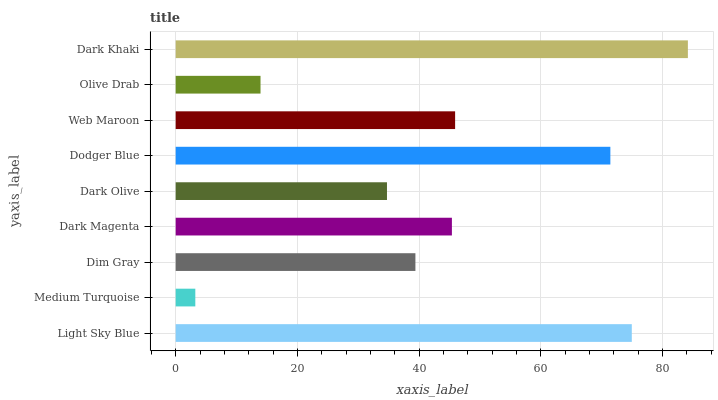Is Medium Turquoise the minimum?
Answer yes or no. Yes. Is Dark Khaki the maximum?
Answer yes or no. Yes. Is Dim Gray the minimum?
Answer yes or no. No. Is Dim Gray the maximum?
Answer yes or no. No. Is Dim Gray greater than Medium Turquoise?
Answer yes or no. Yes. Is Medium Turquoise less than Dim Gray?
Answer yes or no. Yes. Is Medium Turquoise greater than Dim Gray?
Answer yes or no. No. Is Dim Gray less than Medium Turquoise?
Answer yes or no. No. Is Dark Magenta the high median?
Answer yes or no. Yes. Is Dark Magenta the low median?
Answer yes or no. Yes. Is Medium Turquoise the high median?
Answer yes or no. No. Is Dodger Blue the low median?
Answer yes or no. No. 